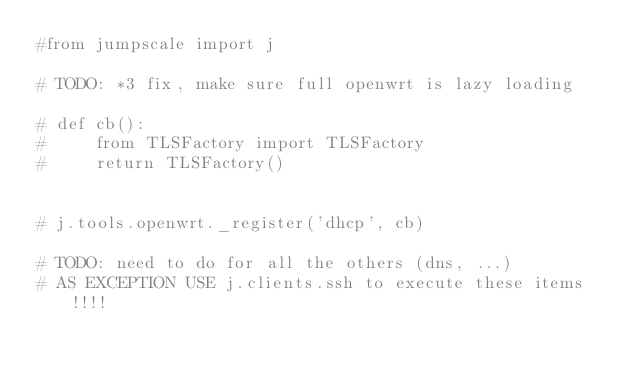<code> <loc_0><loc_0><loc_500><loc_500><_Python_>#from jumpscale import j

# TODO: *3 fix, make sure full openwrt is lazy loading

# def cb():
#     from TLSFactory import TLSFactory
#     return TLSFactory()


# j.tools.openwrt._register('dhcp', cb)

# TODO: need to do for all the others (dns, ...)
# AS EXCEPTION USE j.clients.ssh to execute these items !!!!
</code> 